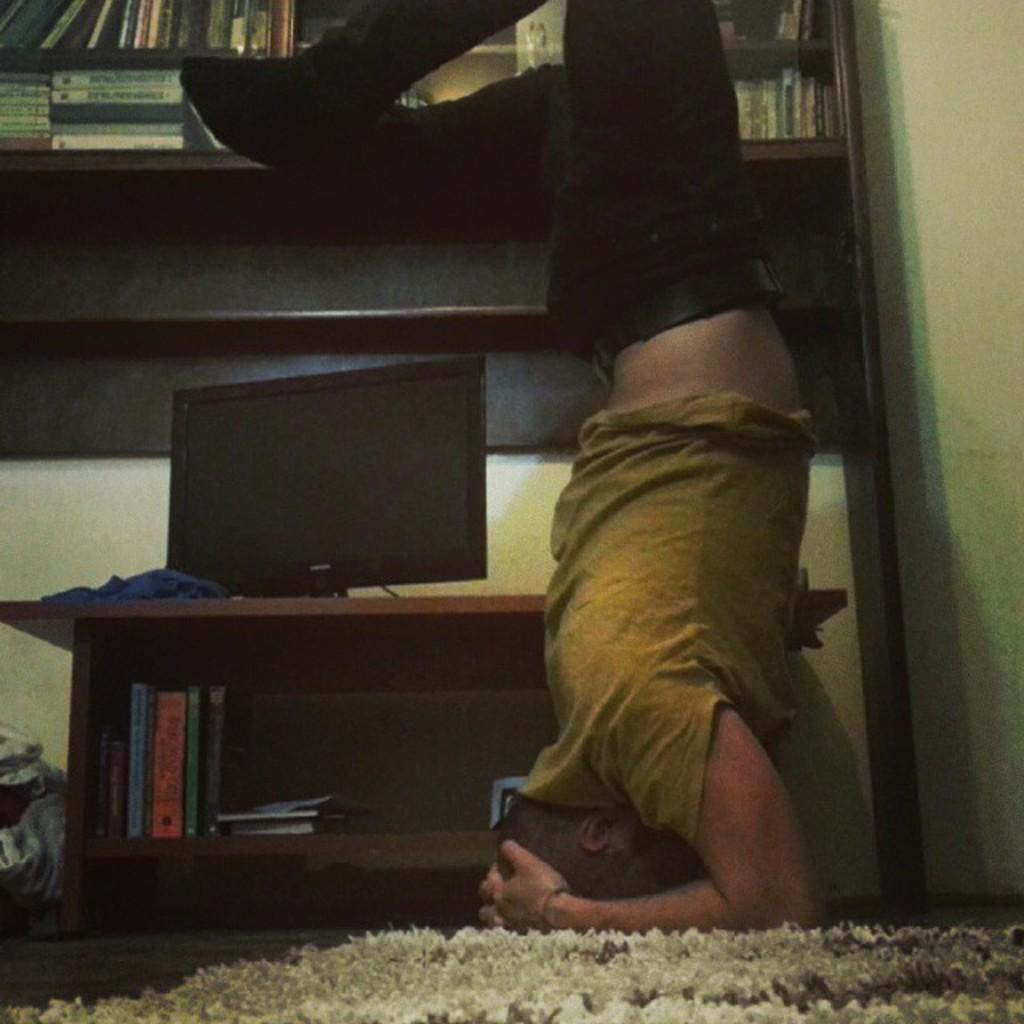Who or what is present in the image? There is a person in the image. What object can be seen on a table in the image? There is a computer on a table in the image. What type of items can be seen in the background of the image? There are books visible in a shelf in the background of the image. What is the person's tendency to run in the image? There is no indication of the person running or having a tendency to run in the image. 